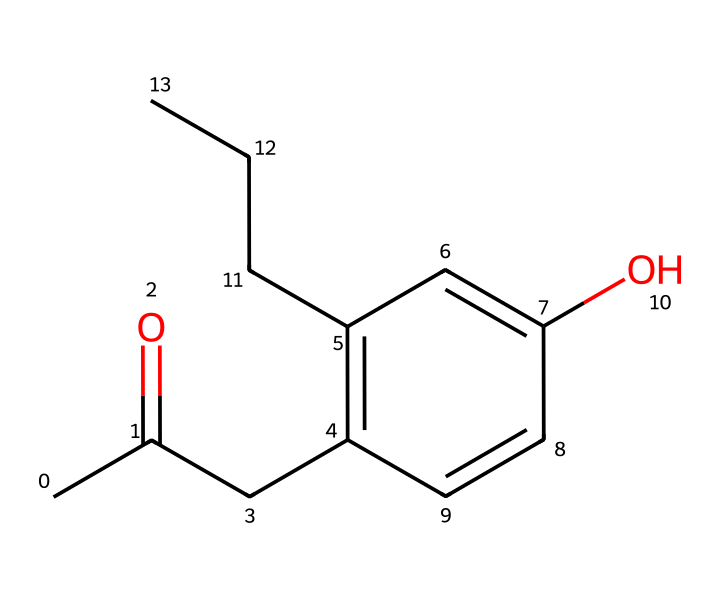What is the class of this compound? This compound contains a carbonyl group (C=O) bonded to a carbon chain, which is characteristic of ketones. Thus, it falls under the class of ketones.
Answer: ketone How many carbon atoms are present in raspberry ketone? By analyzing the SMILES representation, you can count the carbon atoms in the structure. There are 10 carbon atoms in total.
Answer: 10 What is the functional group present in raspberry ketone? The SMILES indicates the presence of a carbonyl (C=O) group, which is the defining functional group of ketones.
Answer: carbonyl How many double bonds are present in the structure? To determine the number of double bonds, we can identify each instance of double (C=C) and carbonyl (C=O) bonds. In this structure, there are 4 double bonds.
Answer: 4 What is the degree of unsaturation in raspberry ketone? The degree of unsaturation can be calculated using the formula: (2C + 2 + N - H - X) / 2. Applying this to raspberry ketone, we find it has a degree of unsaturation of 5.
Answer: 5 Which part of the structure indicates it may have aromatic properties? The presence of a cyclic part with alternating double bonds, specifically the benzene-like structure in the formula, suggests that this compound has aromatic properties.
Answer: aromatic structure Is raspberry ketone a saturated or unsaturated compound? The presence of multiple double bonds indicates that raspberry ketone is not fully saturated, meaning it is considered an unsaturated compound.
Answer: unsaturated 